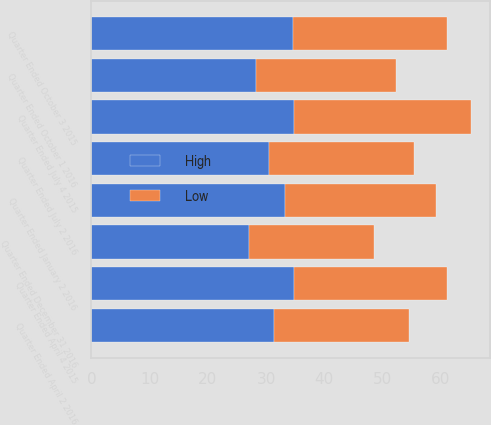<chart> <loc_0><loc_0><loc_500><loc_500><stacked_bar_chart><ecel><fcel>Quarter Ended April 2 2016<fcel>Quarter Ended July 2 2016<fcel>Quarter Ended October 1 2016<fcel>Quarter Ended December 31 2016<fcel>Quarter Ended April 4 2015<fcel>Quarter Ended July 4 2015<fcel>Quarter Ended October 3 2015<fcel>Quarter Ended January 2 2016<nl><fcel>High<fcel>31.36<fcel>30.42<fcel>28.24<fcel>27.07<fcel>34.8<fcel>34.78<fcel>34.67<fcel>33.24<nl><fcel>Low<fcel>23.25<fcel>24.96<fcel>24.14<fcel>21.4<fcel>26.28<fcel>30.42<fcel>26.32<fcel>25.92<nl></chart> 